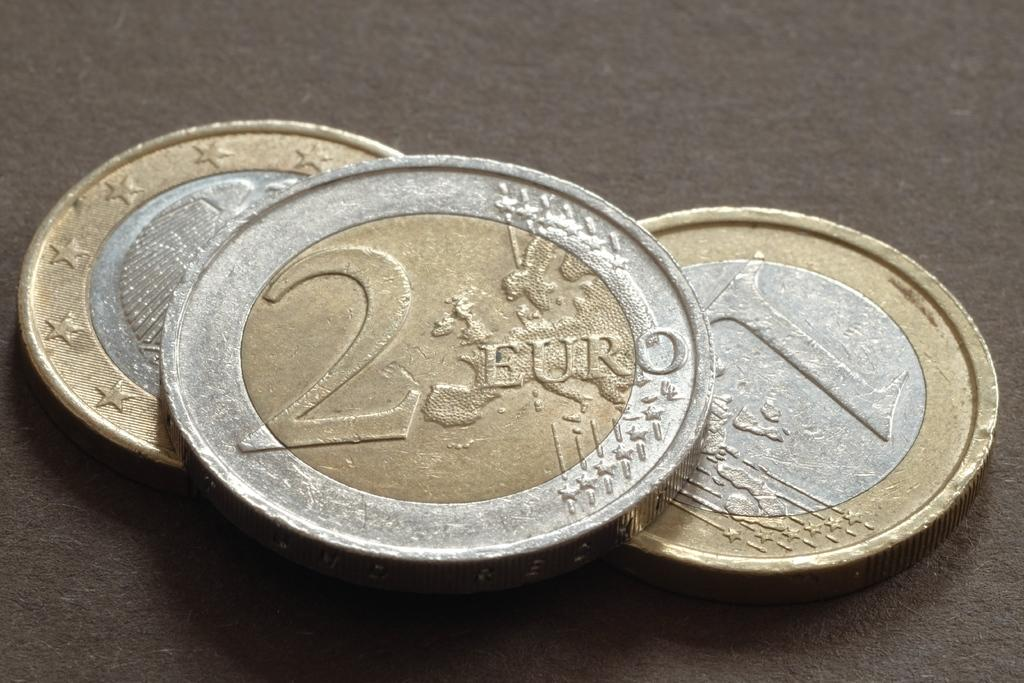<image>
Create a compact narrative representing the image presented. 2 Euro coin on top of a coin with the number 1 on it. 